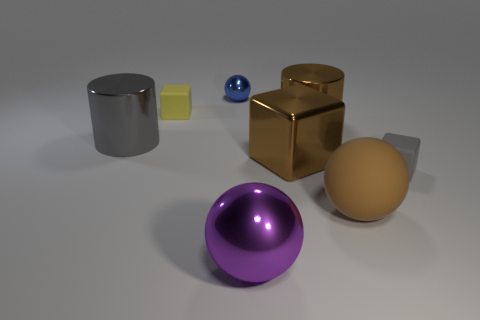What materials appear to be represented by the objects in the image? The objects in the image appear to represent various materials with different textures and reflections. The sphere in the foreground has a shiny, reflective surface suggesting metallic properties, possibly stainless steel or polished aluminum. The cube and the cylinder look like they have a matte finish typical of rubber, and the smaller square and the sphere in the background seem to be glass due to their transparent and reflective qualities. 